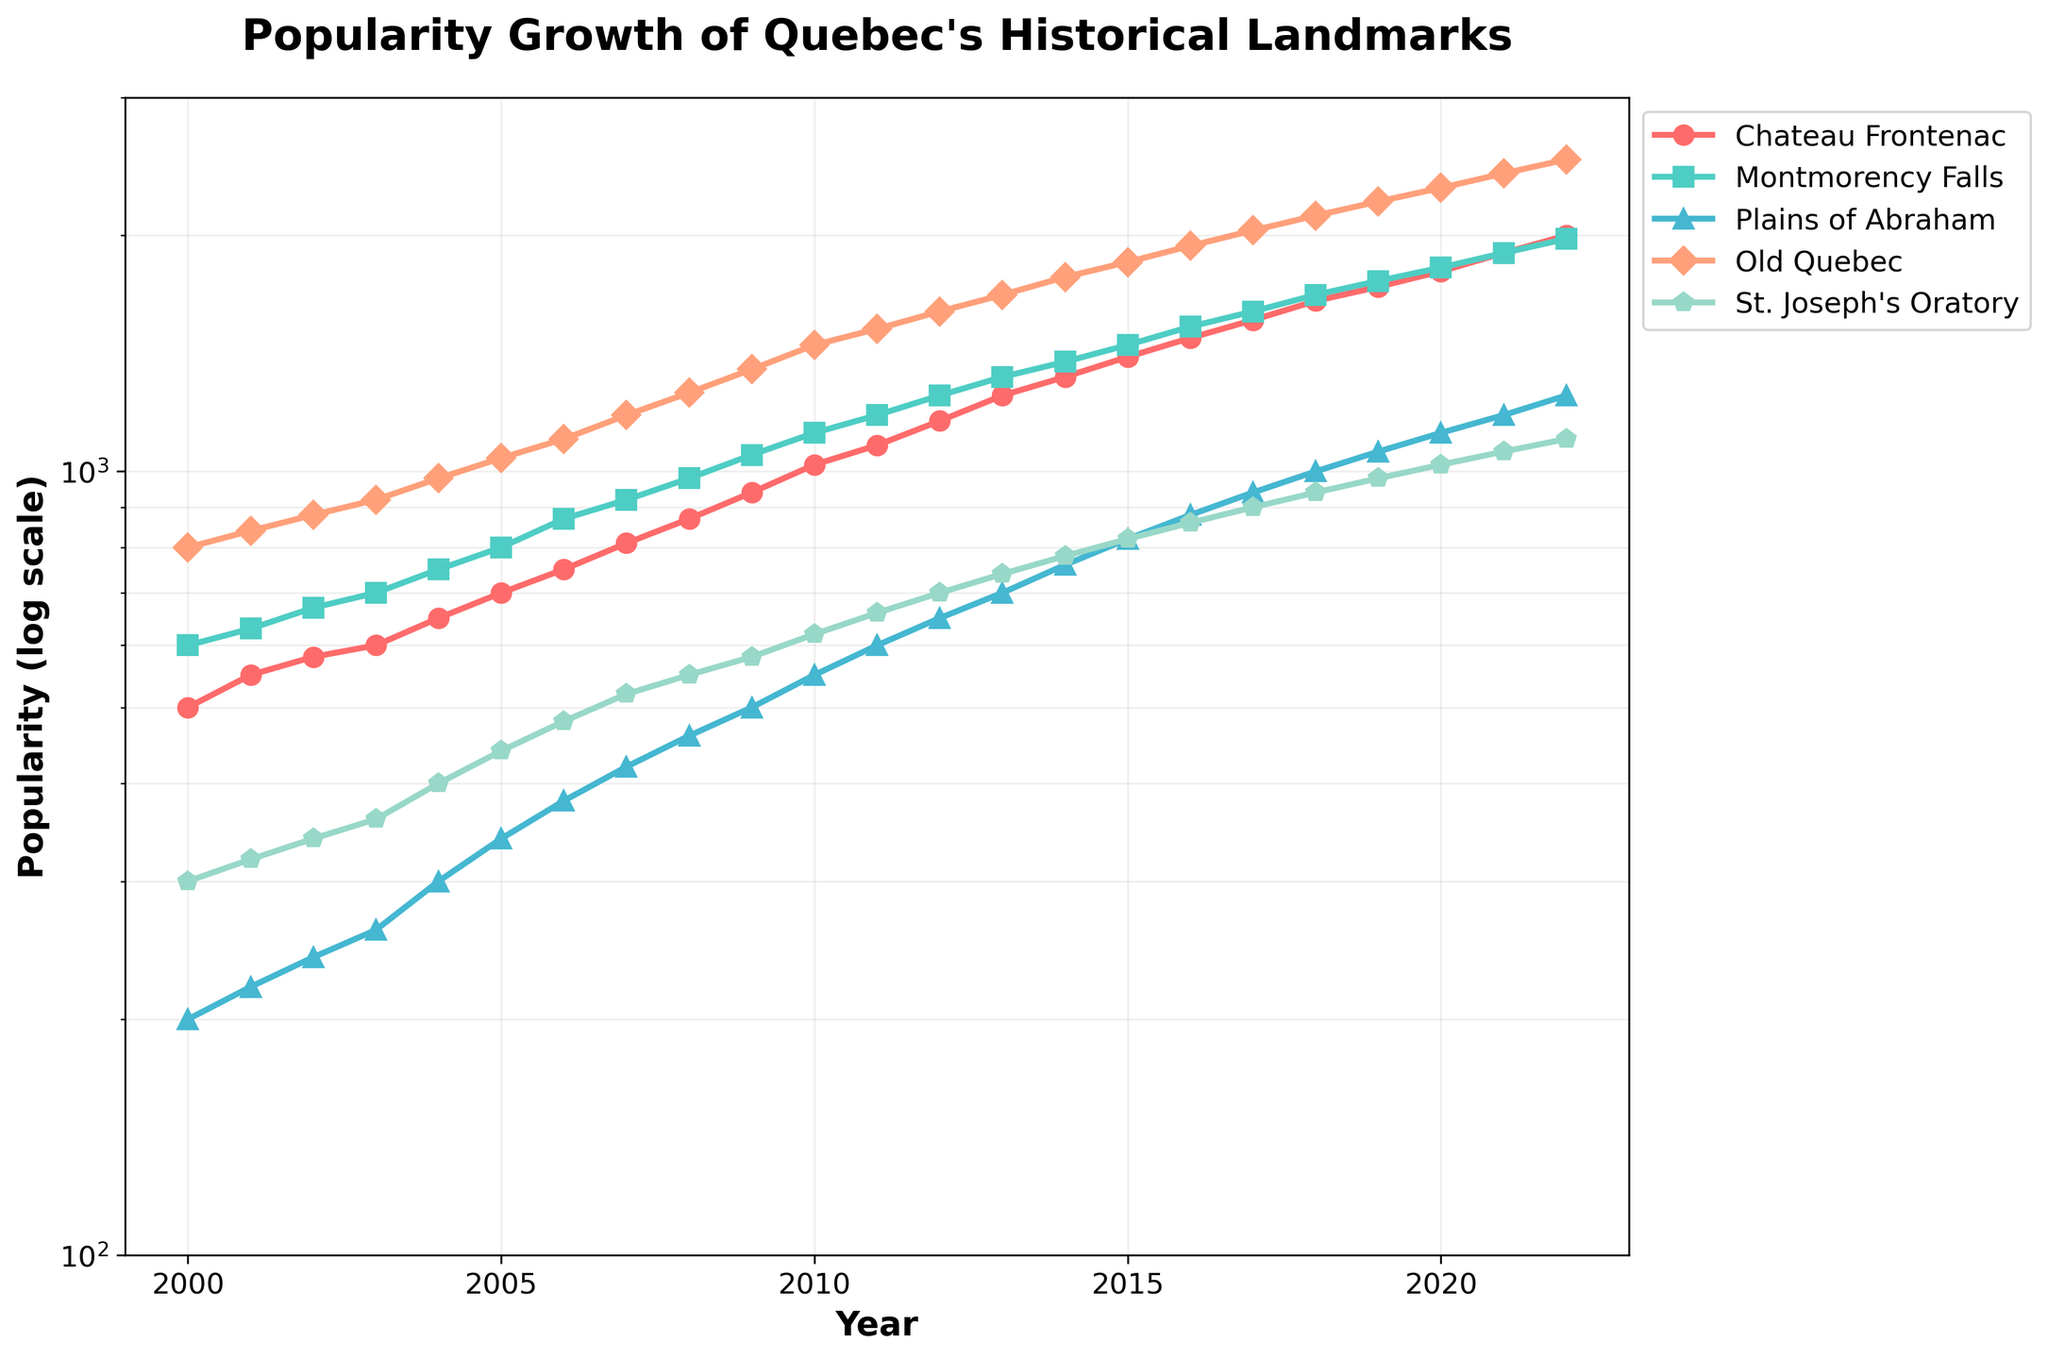What's the title of the figure? The title is usually located at the top of the figure and describes what the plot is about. In this case, the title is clearly stated.
Answer: Popularity Growth of Quebec's Historical Landmarks Which landmark had the highest popularity in 2022? The highest popularity value for the year 2022 needs to be identified from the plot. Old Quebec appears to be the most popular landmark in that year.
Answer: Old Quebec What is the lowest popularity of Montmorency Falls within the given time span? Locate the lowest point on the Montmorency Falls curve over the years from 2000 to 2022. The earliest year, 2000, shows the lowest popularity.
Answer: 600 How has the popularity of Chateau Frontenac changed from 2005 to 2010? Find the values for Chateau Frontenac in 2005 and 2010 and calculate the difference. In 2005, it was 700, and in 2010, it was 1020, indicating a steady increase over these years.
Answer: Increased by 320 Which landmark exhibited the highest growth rate in popularity between 2000 and 2022? Evaluate the overall increase for each landmark between 2000 and 2022, and identify which landmark had the largest increase. Old Quebec increased from 800 to 2500, a growth of 1700.
Answer: Old Quebec What marker and color are used to represent Plains of Abraham? To identify the visual characteristics, look at the legend where Plains of Abraham is labeled. It uses a triangle marker (^) and a blue color.
Answer: Triangle marker (^) and blue color When did St. Joseph's Oratory reach a popularity of 1000 for the first time? Tracking the St. Joseph's Oratory curve until it crosses the 1000 mark, this occurs around 2020.
Answer: 2020 Compare the popularity of Old Quebec and Chateau Frontenac in 2015. Which one had a greater popularity? Locate the values of Old Quebec and Chateau Frontenac in 2015 on the plot. Old Quebec was at 1850 and Chateau Frontenac at 1400. Clearly, Old Quebec was more popular.
Answer: Old Quebec What has been the trend in popularity for all landmarks from 2000 to 2022? Observing the overall trend lines for all landmarks, each line shows an upward trend, indicating an increase in popularity over time.
Answer: Increasing Which landmark had the slowest growth rate between 2005 and 2015? Calculate the difference for each landmark between 2005 and 2015, and see which one had the smallest increase. St. Joseph's Oratory grew by 380 (from 440 to 820), the smallest increment among all landmarks.
Answer: St. Joseph's Oratory 